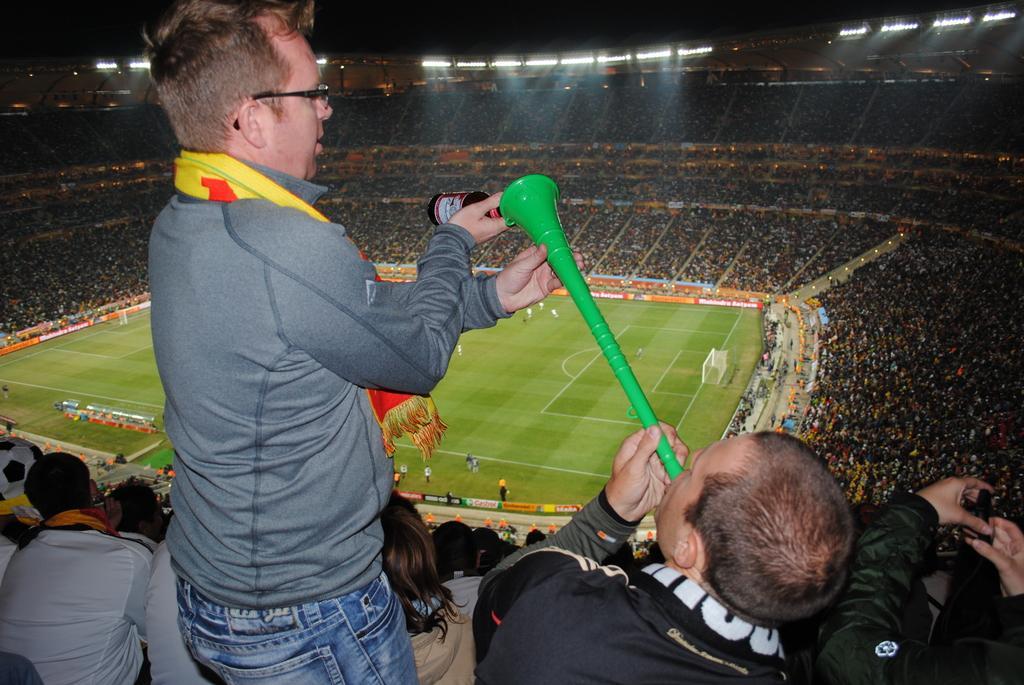Describe this image in one or two sentences. This is a stadium. In the middle of the image there is a ground and few people are playing a game. At the bottom there is a man holding a musical instrument in the hand. On the left side there is another man wearing t-shirt, jeans, standing, holding a bottle in the hand and looking at the musical instrument. In the background I can see a crowd of people sitting in the stadium. At the top of the image there are few lights in the dark. 